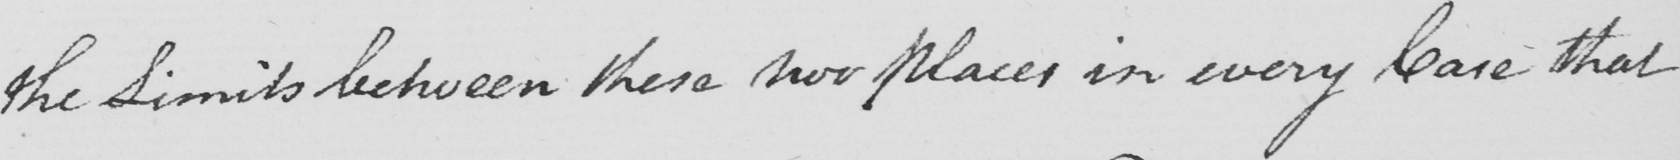What text is written in this handwritten line? the Limits between these two Places in every Case that 